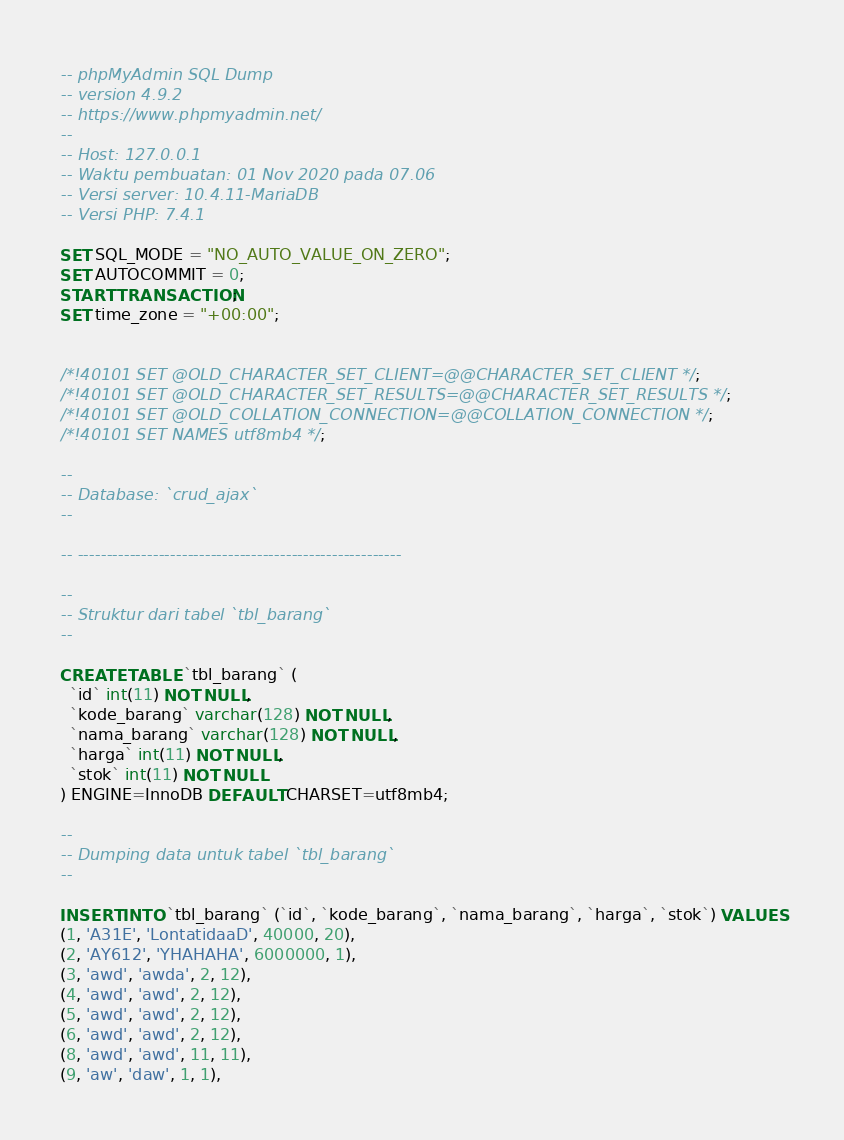<code> <loc_0><loc_0><loc_500><loc_500><_SQL_>-- phpMyAdmin SQL Dump
-- version 4.9.2
-- https://www.phpmyadmin.net/
--
-- Host: 127.0.0.1
-- Waktu pembuatan: 01 Nov 2020 pada 07.06
-- Versi server: 10.4.11-MariaDB
-- Versi PHP: 7.4.1

SET SQL_MODE = "NO_AUTO_VALUE_ON_ZERO";
SET AUTOCOMMIT = 0;
START TRANSACTION;
SET time_zone = "+00:00";


/*!40101 SET @OLD_CHARACTER_SET_CLIENT=@@CHARACTER_SET_CLIENT */;
/*!40101 SET @OLD_CHARACTER_SET_RESULTS=@@CHARACTER_SET_RESULTS */;
/*!40101 SET @OLD_COLLATION_CONNECTION=@@COLLATION_CONNECTION */;
/*!40101 SET NAMES utf8mb4 */;

--
-- Database: `crud_ajax`
--

-- --------------------------------------------------------

--
-- Struktur dari tabel `tbl_barang`
--

CREATE TABLE `tbl_barang` (
  `id` int(11) NOT NULL,
  `kode_barang` varchar(128) NOT NULL,
  `nama_barang` varchar(128) NOT NULL,
  `harga` int(11) NOT NULL,
  `stok` int(11) NOT NULL
) ENGINE=InnoDB DEFAULT CHARSET=utf8mb4;

--
-- Dumping data untuk tabel `tbl_barang`
--

INSERT INTO `tbl_barang` (`id`, `kode_barang`, `nama_barang`, `harga`, `stok`) VALUES
(1, 'A31E', 'LontatidaaD', 40000, 20),
(2, 'AY612', 'YHAHAHA', 6000000, 1),
(3, 'awd', 'awda', 2, 12),
(4, 'awd', 'awd', 2, 12),
(5, 'awd', 'awd', 2, 12),
(6, 'awd', 'awd', 2, 12),
(8, 'awd', 'awd', 11, 11),
(9, 'aw', 'daw', 1, 1),</code> 